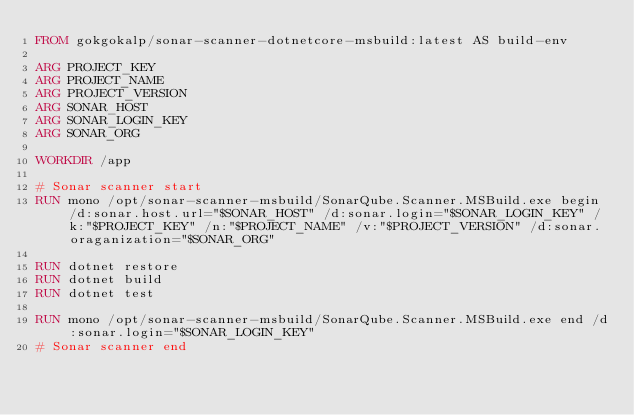<code> <loc_0><loc_0><loc_500><loc_500><_Dockerfile_>FROM gokgokalp/sonar-scanner-dotnetcore-msbuild:latest AS build-env

ARG PROJECT_KEY
ARG PROJECT_NAME
ARG PROJECT_VERSION
ARG SONAR_HOST
ARG SONAR_LOGIN_KEY
ARG SONAR_ORG

WORKDIR /app

# Sonar scanner start
RUN mono /opt/sonar-scanner-msbuild/SonarQube.Scanner.MSBuild.exe begin /d:sonar.host.url="$SONAR_HOST" /d:sonar.login="$SONAR_LOGIN_KEY" /k:"$PROJECT_KEY" /n:"$PROJECT_NAME" /v:"$PROJECT_VERSION" /d:sonar.oraganization="$SONAR_ORG"

RUN dotnet restore
RUN dotnet build
RUN dotnet test

RUN mono /opt/sonar-scanner-msbuild/SonarQube.Scanner.MSBuild.exe end /d:sonar.login="$SONAR_LOGIN_KEY"
# Sonar scanner end</code> 